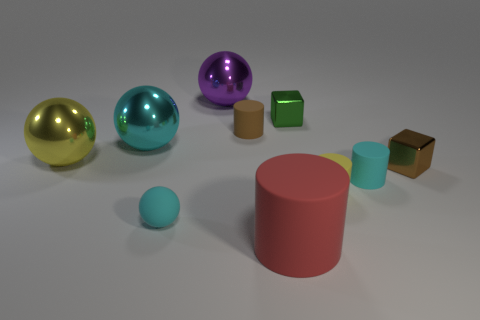Are there any other things that have the same material as the big yellow thing?
Provide a short and direct response. Yes. Do the yellow cylinder and the block that is behind the yellow sphere have the same size?
Ensure brevity in your answer.  Yes. The tiny cube that is left of the metal block to the right of the tiny object that is behind the brown matte object is what color?
Give a very brief answer. Green. Do the cyan object right of the cyan rubber sphere and the large purple sphere have the same material?
Provide a succinct answer. No. What number of other things are made of the same material as the small cyan cylinder?
Your response must be concise. 4. There is a cylinder that is the same size as the purple shiny ball; what is its material?
Give a very brief answer. Rubber. Does the yellow thing that is to the right of the large purple sphere have the same shape as the small cyan thing that is to the left of the tiny brown cylinder?
Make the answer very short. No. There is a brown matte object that is the same size as the yellow matte object; what is its shape?
Your answer should be very brief. Cylinder. Are the ball that is in front of the yellow shiny object and the small brown object in front of the tiny brown cylinder made of the same material?
Provide a succinct answer. No. There is a large ball that is to the right of the rubber sphere; is there a tiny cylinder that is behind it?
Your answer should be compact. No. 